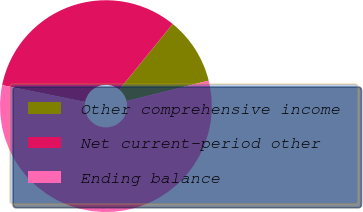<chart> <loc_0><loc_0><loc_500><loc_500><pie_chart><fcel>Other comprehensive income<fcel>Net current-period other<fcel>Ending balance<nl><fcel>10.28%<fcel>32.68%<fcel>57.05%<nl></chart> 